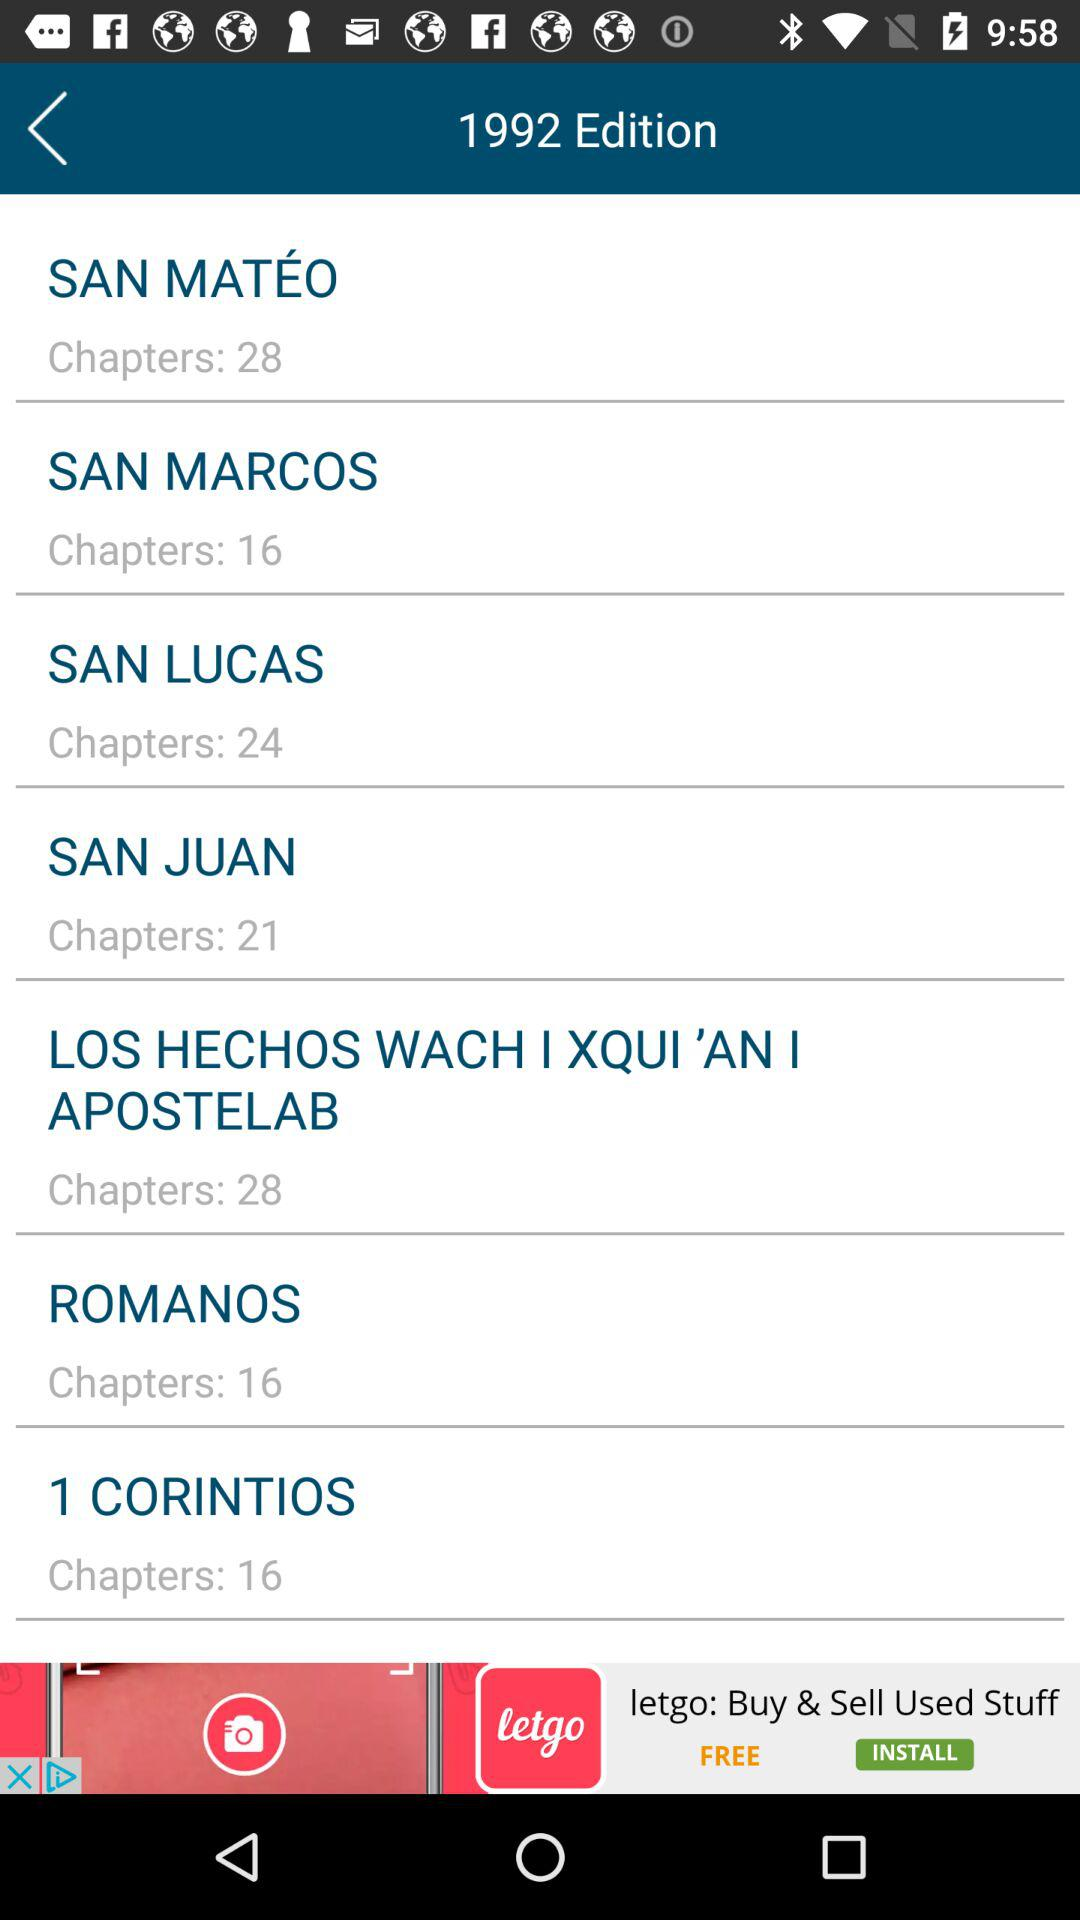How many chapters are in the book of Romans?
Answer the question using a single word or phrase. 16 